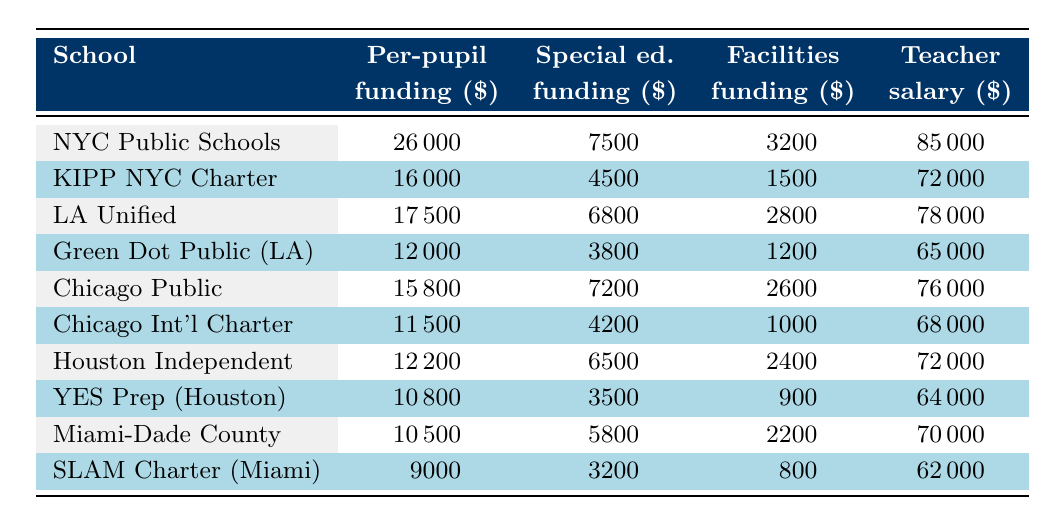What is the per-pupil funding for KIPP NYC Charter Schools? The table indicates that KIPP NYC Charter Schools have a per-pupil funding of $16,000.
Answer: 16,000 Which school receives the highest amount of special education funding? According to the table, New York City Public Schools receive the highest special education funding at $7,500.
Answer: 7,500 What is the difference in teacher salary between New York City Public Schools and SLAM Charter School? From the table, New York City Public Schools have a teacher salary of $85,000, while SLAM Charter School has $62,000. The difference is $85,000 - $62,000 = $23,000.
Answer: 23,000 Do all charter schools in the table have less per-pupil funding than New York City Public Schools? The table shows that all listed charter schools have lower per-pupil funding compared to $26,000 from New York City Public Schools, confirming that the statement is true.
Answer: Yes What is the average federal funding allocation percentage for the charter schools in the table? The federal funding allocations for charter schools are 6%, 6%, 6%, and 6%. Calculating the average: (6 + 6 + 6 + 6) / 4 = 6%.
Answer: 6% How much more facilities funding does Los Angeles Unified School District receive compared to Green Dot Public Schools? The table states that Los Angeles Unified School District receives $2,800 for facilities funding, while Green Dot Public Schools receive $1,200. The difference is $2,800 - $1,200 = $1,600.
Answer: 1,600 Is the state funding allocation percentage for Chicago International Charter School greater than for yes Prep Public Schools? Chicago International Charter School's state funding allocation is 70%, while YES Prep has 68%. Since 70% is greater than 68%, the statement is true.
Answer: Yes Calculating the total amount of special education funding for all schools listed in the table? Summing up the special education funding from all schools: 7500 + 4500 + 6800 + 3800 + 7200 + 4200 + 6500 + 3500 + 5800 + 3200 = 40000.
Answer: 40,000 Which school has the highest percentage of local funding allocation? The highest local funding allocation percentage in the table is for Miami-Dade County Public Schools at 44%.
Answer: 44% How do the transportation funding amounts compare for Houston Independent School District and YES Prep Public Schools? Houston Independent receives $1,400, and YES Prep receives $900. Thus, Houston Independent receives $1,400 - $900 = $500 more.
Answer: 500 